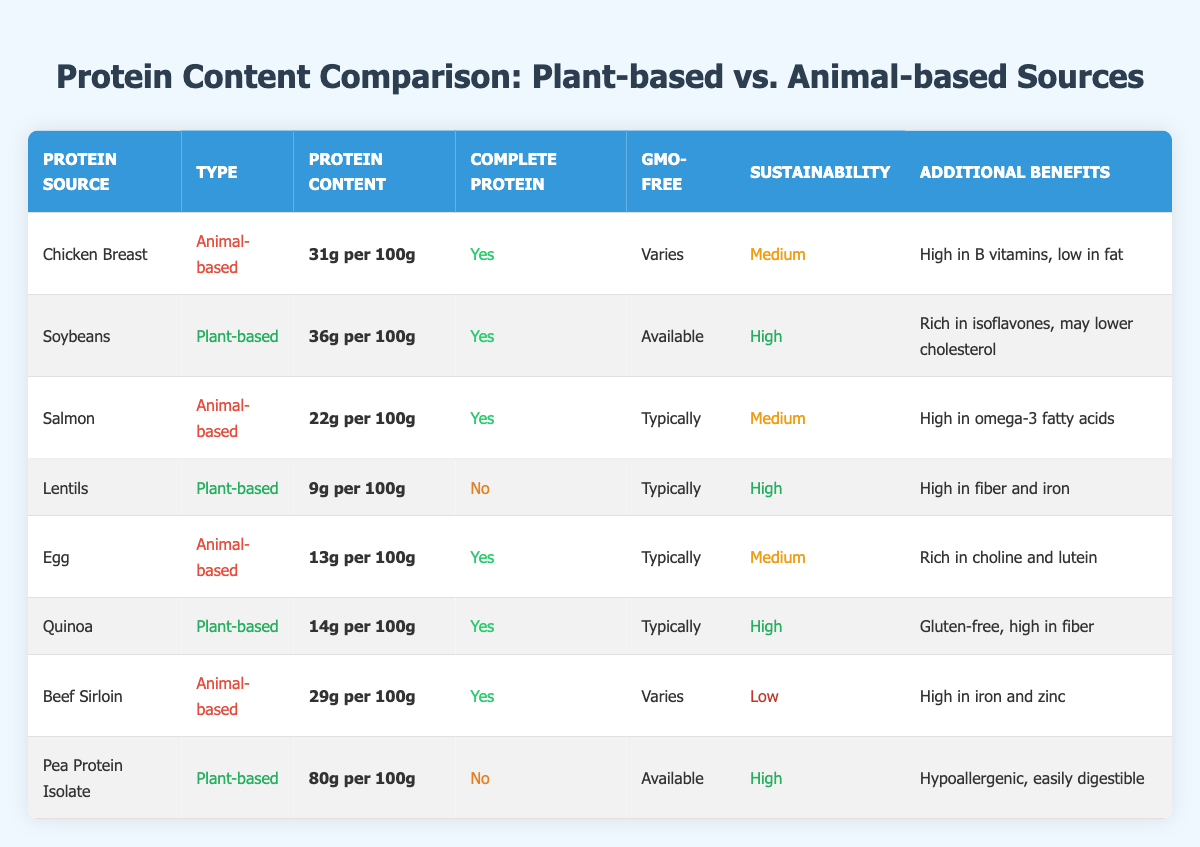What is the protein content of Soybeans? The protein content of Soybeans is listed in the table, specifically under the "Protein Content" column. It states that Soybeans contain 36 grams of protein per 100 grams.
Answer: 36 grams per 100g Which protein source has the highest protein content? By examining the "Protein Content" column, Pea Protein Isolate is identified with the highest protein content at 80 grams per 100 grams.
Answer: Pea Protein Isolate Is Lentils considered a complete protein? The table indicates under the "Complete Protein" column that Lentils are marked as "No," meaning they do not provide all essential amino acids necessary.
Answer: No How does the sustainability of Beef Sirloin compare to Chicken Breast? The sustainability rating for Beef Sirloin is "Low" and for Chicken Breast is "Medium." Thus, Chicken Breast is considered more sustainable than Beef Sirloin.
Answer: Chicken Breast is more sustainable What is the average protein content for Animal-based protein sources listed? To find the average, sum the protein contents of Chicken Breast (31g), Salmon (22g), Egg (13g), and Beef Sirloin (29g) which equals 95 grams. There are four entries, so the average is 95g / 4 = 23.75g per 100g.
Answer: 23.75 grams per 100g How many plant-based sources are GMO-free? Checking the "GMO-Free" column reveals that Soybeans and Pea Protein Isolate are labeled as "Available" for GMO-free, while the others are marked as "Typically." Therefore, only Soybeans and Pea Protein Isolate can be confirmed as GMO-free options.
Answer: 2 plant-based sources What are the additional benefits of Quinoa? The table provides a description in the "Additional Benefits" column for Quinoa, indicating that it is gluten-free and high in fiber, making it beneficial for those with gluten sensitivities or looking to increase fiber intake.
Answer: Gluten-free, high in fiber Which protein sources have a sustainability rating of "High"? Referring to the "Sustainability" column, both Soybeans, Lentils, Quinoa, and Pea Protein Isolate are rated as "High." Thus, these four sources are the ones with high sustainability ratings.
Answer: 4 sources (Soybeans, Lentils, Quinoa, Pea Protein Isolate) 